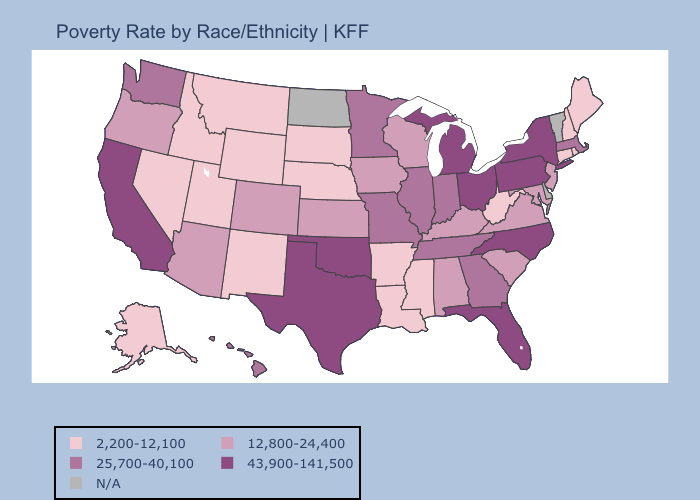Which states have the highest value in the USA?
Give a very brief answer. California, Florida, Michigan, New York, North Carolina, Ohio, Oklahoma, Pennsylvania, Texas. What is the value of Illinois?
Keep it brief. 25,700-40,100. What is the lowest value in the West?
Keep it brief. 2,200-12,100. What is the lowest value in the USA?
Be succinct. 2,200-12,100. Which states have the lowest value in the USA?
Quick response, please. Alaska, Arkansas, Connecticut, Idaho, Louisiana, Maine, Mississippi, Montana, Nebraska, Nevada, New Hampshire, New Mexico, Rhode Island, South Dakota, Utah, West Virginia, Wyoming. Name the states that have a value in the range 2,200-12,100?
Concise answer only. Alaska, Arkansas, Connecticut, Idaho, Louisiana, Maine, Mississippi, Montana, Nebraska, Nevada, New Hampshire, New Mexico, Rhode Island, South Dakota, Utah, West Virginia, Wyoming. What is the value of Maine?
Write a very short answer. 2,200-12,100. What is the value of New Jersey?
Answer briefly. 12,800-24,400. What is the value of Kentucky?
Quick response, please. 12,800-24,400. Which states have the lowest value in the South?
Give a very brief answer. Arkansas, Louisiana, Mississippi, West Virginia. How many symbols are there in the legend?
Quick response, please. 5. What is the value of Washington?
Short answer required. 25,700-40,100. What is the lowest value in the West?
Give a very brief answer. 2,200-12,100. What is the value of New York?
Quick response, please. 43,900-141,500. 